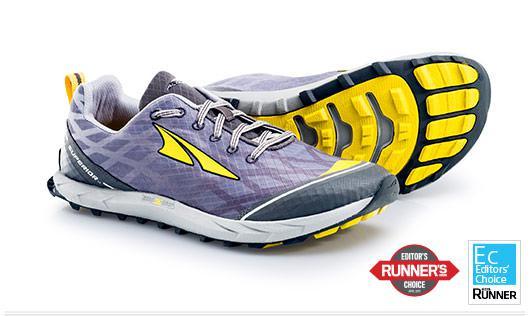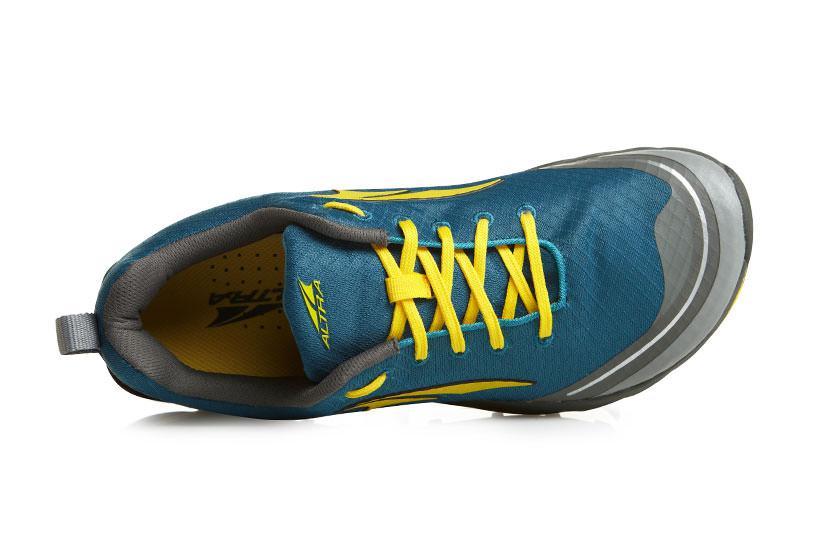The first image is the image on the left, the second image is the image on the right. Considering the images on both sides, is "One of the three sneakers has yellow shoe laces and it is not laying on it's side." valid? Answer yes or no. No. The first image is the image on the left, the second image is the image on the right. For the images shown, is this caption "In at least one photo there is a teal shoe with gray trimming and yellow laces facing right." true? Answer yes or no. Yes. 